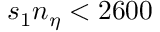<formula> <loc_0><loc_0><loc_500><loc_500>s _ { 1 } n _ { \eta } < 2 6 0 0</formula> 